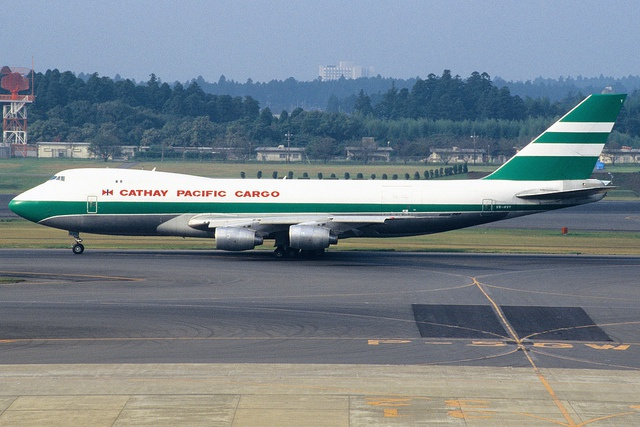Describe the objects in this image and their specific colors. I can see a airplane in lightblue, white, teal, black, and gray tones in this image. 